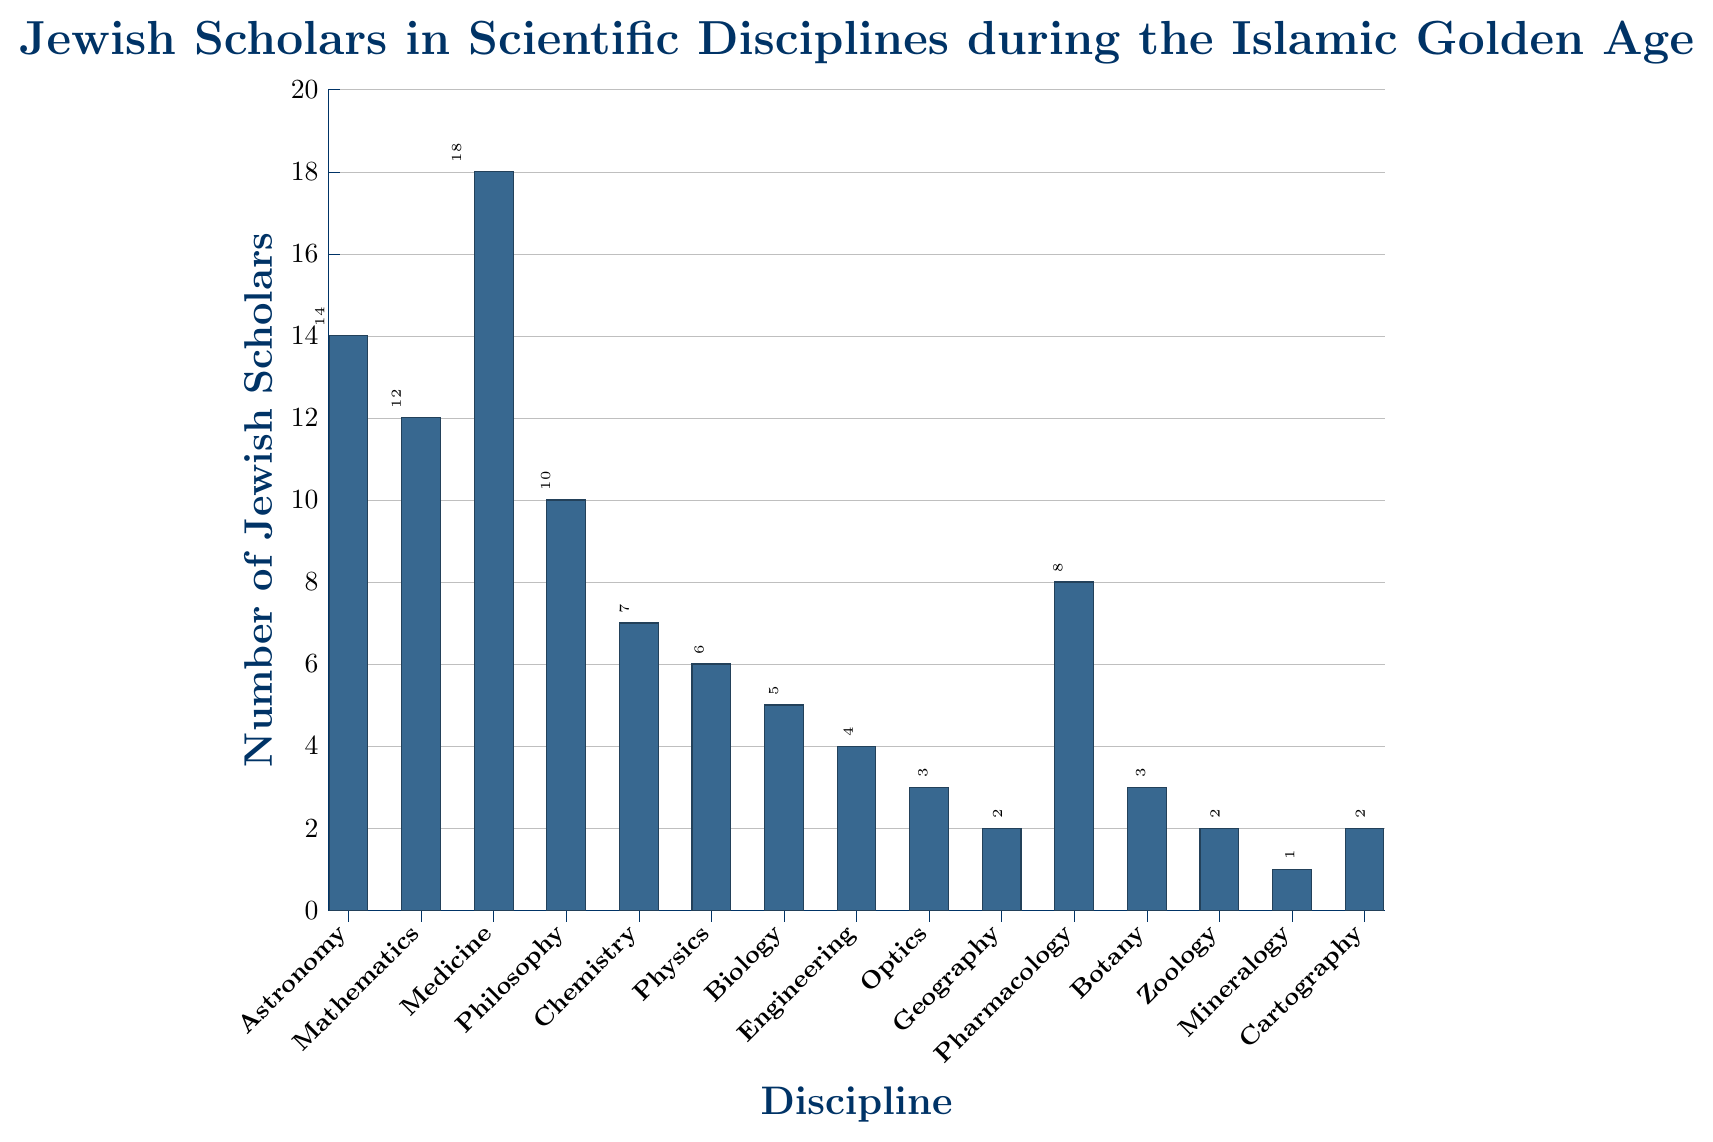What's the most represented scientific discipline by Jewish scholars during the Islamic Golden Age? The bar for Medicine is the tallest in the figure, indicating it has the highest number of Jewish scholars.
Answer: Medicine Which disciplines have fewer than 5 Jewish scholars? By observing the bars that are shorter than 5 units on the y-axis, we see that Engineering, Optics, Geography, Zoology, Mineralogy, and Cartography have fewer than 5 Jewish scholars.
Answer: Engineering, Optics, Geography, Zoology, Mineralogy, Cartography How many more Jewish scholars are in Medicine compared to Geography? The bar for Medicine reaches 18, while the bar for Geography reaches 2. Subtracting the latter from the former gives 18 - 2 = 16.
Answer: 16 What's the sum of Jewish scholars in Mathematics and Physics? The number of Jewish scholars in Mathematics is 12 and in Physics is 6. Adding them together gives 12 + 6 = 18.
Answer: 18 Are there more Jewish scholars in pharmacology than in chemistry? The height of the bar for Pharmacology is 8, whereas the height of the bar for Chemistry is 7. Therefore, there are more Jewish scholars in Pharmacology than in Chemistry.
Answer: Yes What is the average number of Jewish scholars across all disciplines? Summing all the numbers (14 + 12 + 18 + 10 + 7 + 6 + 5 + 4 + 3 + 2 + 8 + 3 + 2 + 1 + 2) gives a total of 97. There are 15 disciplines, so the average is 97 / 15 = 6.47 (rounded to two decimal places).
Answer: 6.47 Which two disciplines have the same number of Jewish scholars, and what is that number? By examining the heights of the bars, we see that Geography, Zoology, and Cartography each have 2 Jewish scholars.
Answer: Geography, Zoology, Cartography - 2 What's the total number of Jewish scholars in disciplines categorized under biology-related fields (Biology, Botany, and Zoology)? The bars for Biology, Botany, and Zoology stand at 5, 3, and 2 respectively. Adding these together gives 5 + 3 + 2 = 10.
Answer: 10 Which discipline has the smallest number of Jewish scholars, and what is that number? Mineralogy has the smallest number of Jewish scholars with a bar height reaching 1.
Answer: Mineralogy - 1 